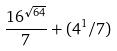<formula> <loc_0><loc_0><loc_500><loc_500>\frac { 1 6 ^ { \sqrt { 6 4 } } } { 7 } + ( 4 ^ { 1 } / 7 )</formula> 